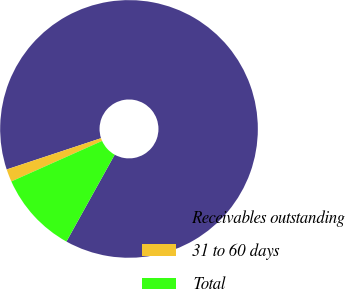Convert chart to OTSL. <chart><loc_0><loc_0><loc_500><loc_500><pie_chart><fcel>Receivables outstanding<fcel>31 to 60 days<fcel>Total<nl><fcel>88.17%<fcel>1.59%<fcel>10.25%<nl></chart> 